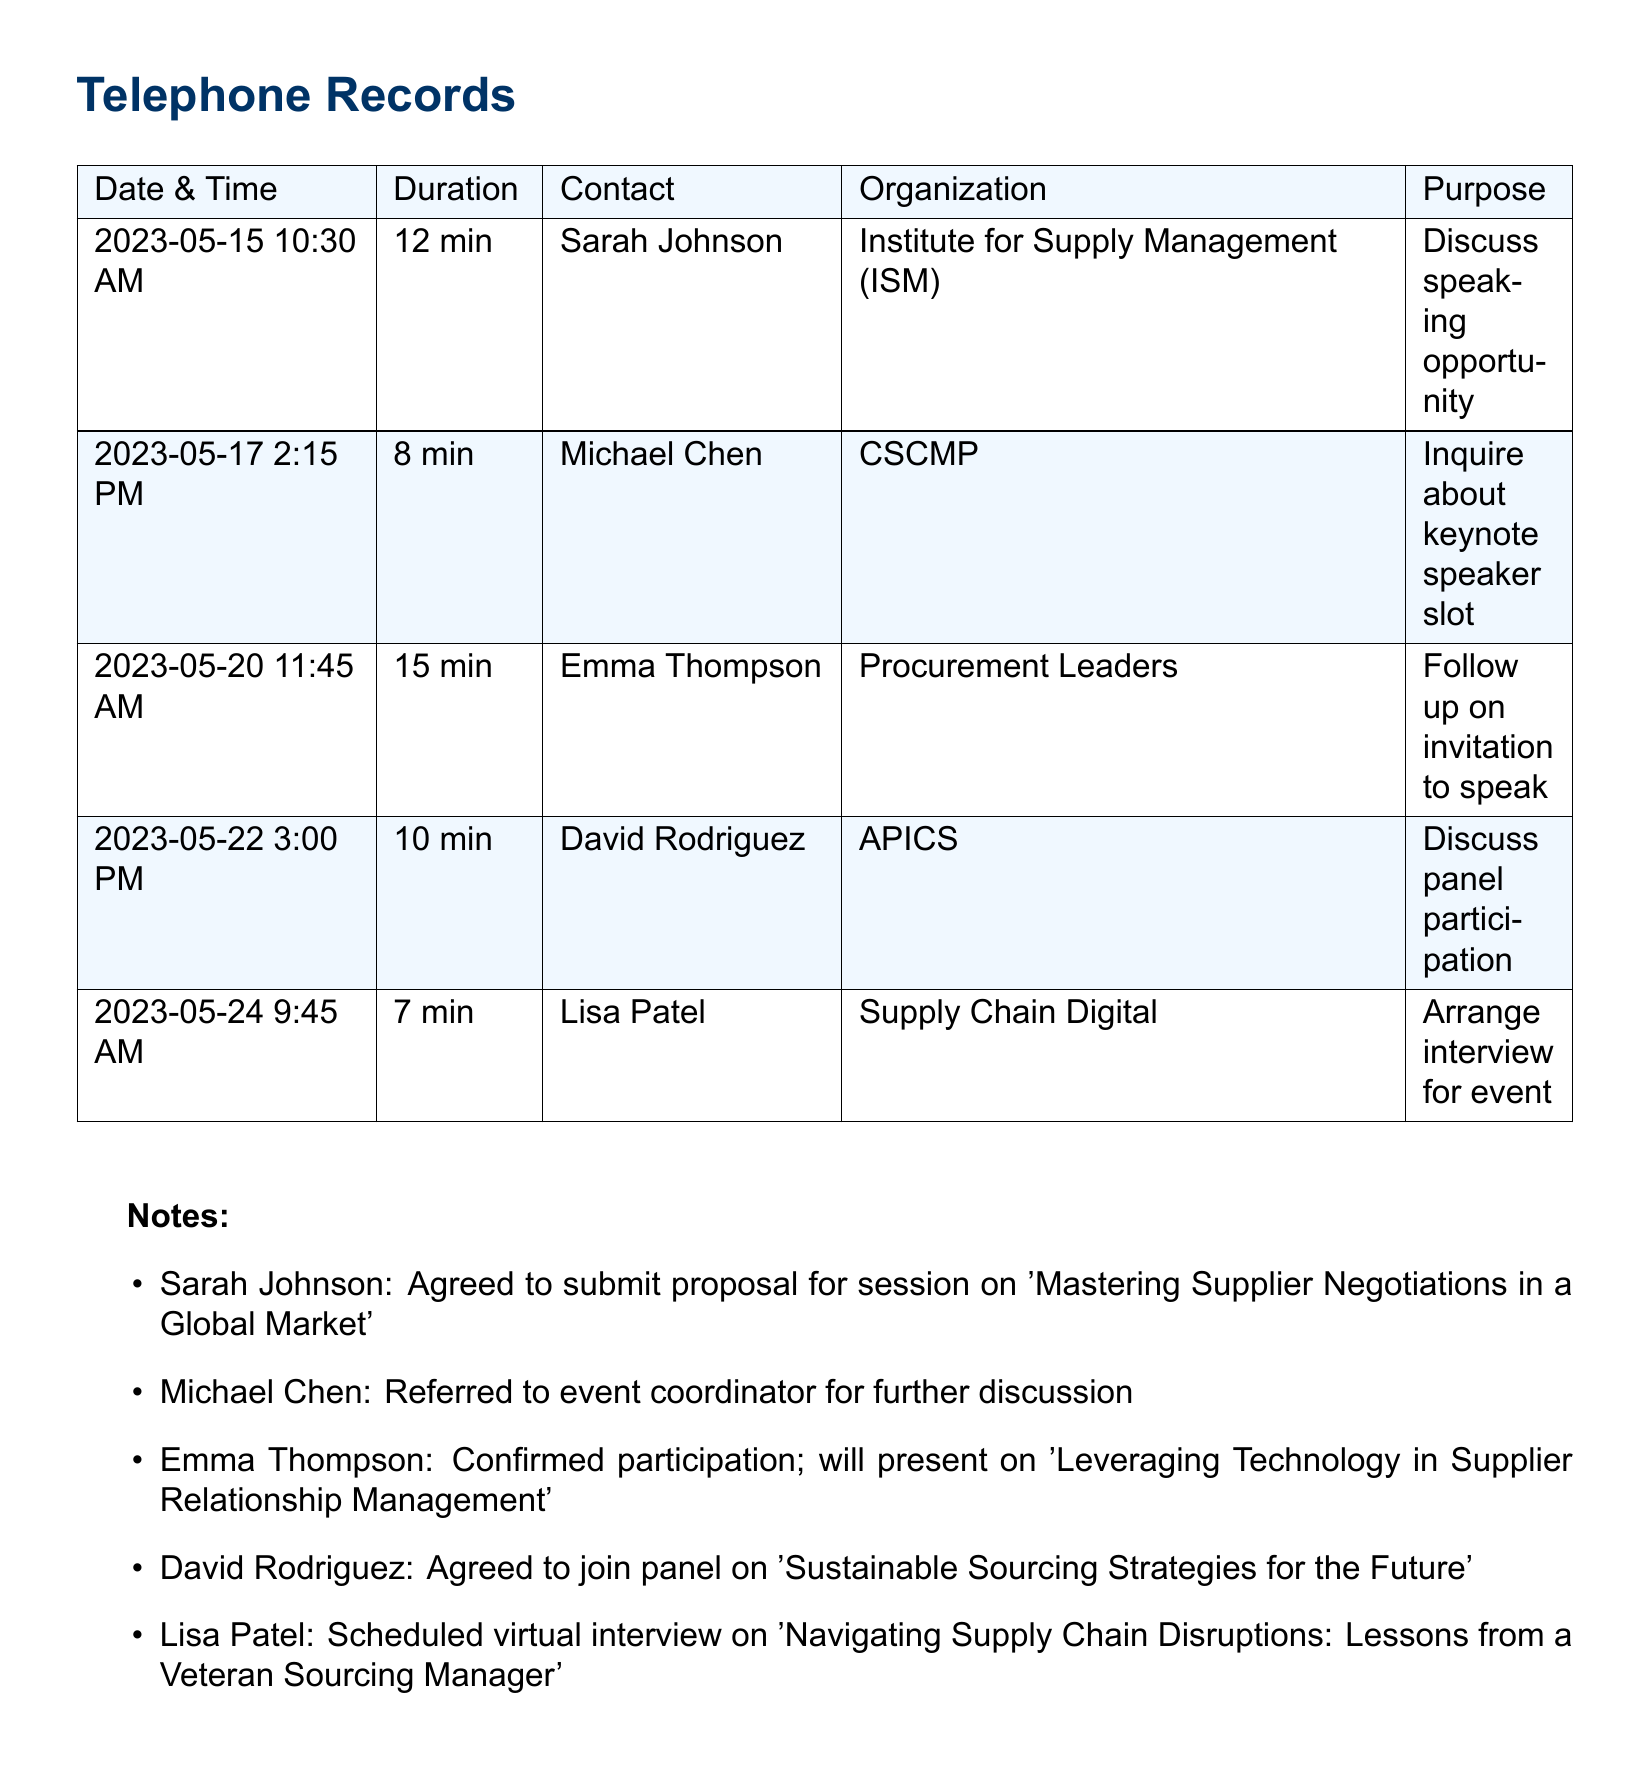What is the date of the call with Sarah Johnson? The date of the call with Sarah Johnson is specifically listed as May 15, 2023.
Answer: May 15, 2023 How long was the call with Michael Chen? The duration of the call with Michael Chen is provided as 8 minutes.
Answer: 8 min What organization does Emma Thompson represent? The document specifies that Emma Thompson is associated with Procurement Leaders.
Answer: Procurement Leaders What was the purpose of the call with David Rodriguez? The purpose of the call with David Rodriguez was to discuss panel participation.
Answer: Discuss panel participation Which topic will Emma Thompson present on? The document mentions that Emma Thompson will present on 'Leveraging Technology in Supplier Relationship Management'.
Answer: Leveraging Technology in Supplier Relationship Management How many minutes was the call with Lisa Patel? The duration for the call with Lisa Patel is given as 7 minutes.
Answer: 7 min Who agreed to join a panel on sustainable sourcing strategies? David Rodriguez is noted as having agreed to join the panel on this topic.
Answer: David Rodriguez What follow-up action was taken after the call with Emma Thompson? The follow-up action noted is that Emma Thompson confirmed her participation to speak.
Answer: Confirmed participation What was the main subject of the proposed session by Sarah Johnson? Sarah Johnson proposed a session on 'Mastering Supplier Negotiations in a Global Market'.
Answer: Mastering Supplier Negotiations in a Global Market Which contact was referred to the event coordinator? The document indicates that Michael Chen was the contact referred to the event coordinator.
Answer: Michael Chen 